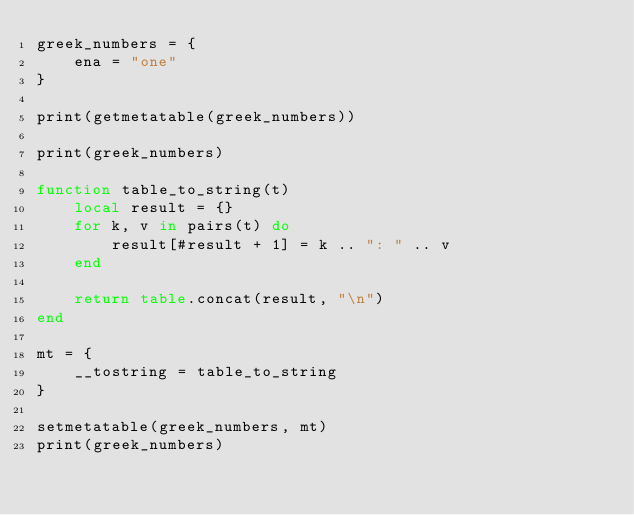<code> <loc_0><loc_0><loc_500><loc_500><_Lua_>greek_numbers = {
    ena = "one"
}

print(getmetatable(greek_numbers))

print(greek_numbers)

function table_to_string(t)
    local result = {}
    for k, v in pairs(t) do
        result[#result + 1] = k .. ": " .. v
    end
    
    return table.concat(result, "\n")
end

mt = {
    __tostring = table_to_string
}

setmetatable(greek_numbers, mt)
print(greek_numbers)</code> 